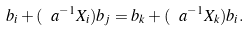Convert formula to latex. <formula><loc_0><loc_0><loc_500><loc_500>b _ { i } + ( \ a ^ { - 1 } X _ { i } ) b _ { j } = b _ { k } + ( \ a ^ { - 1 } X _ { k } ) b _ { i } .</formula> 